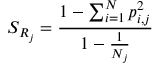<formula> <loc_0><loc_0><loc_500><loc_500>S _ { R _ { j } } = \frac { 1 - \sum _ { i = 1 } ^ { N } p _ { i , j } ^ { 2 } } { 1 - \frac { 1 } { N _ { j } } }</formula> 